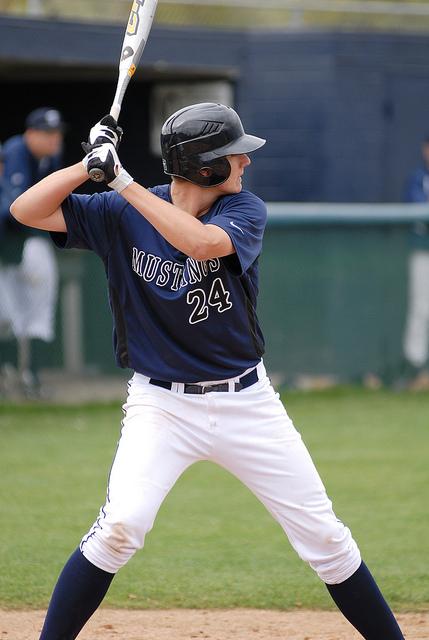What position does this player play?
Quick response, please. Batter. What is he waiting for?
Write a very short answer. Ball. What team does he belong to?
Keep it brief. Mustangs. Is this person right or left handed?
Concise answer only. Right. What is the man doing?
Short answer required. Batting. What hand is he holding the bat with?
Answer briefly. Right. What is on the batter's head?
Answer briefly. Helmet. Who does he play for?
Give a very brief answer. Mustangs. 